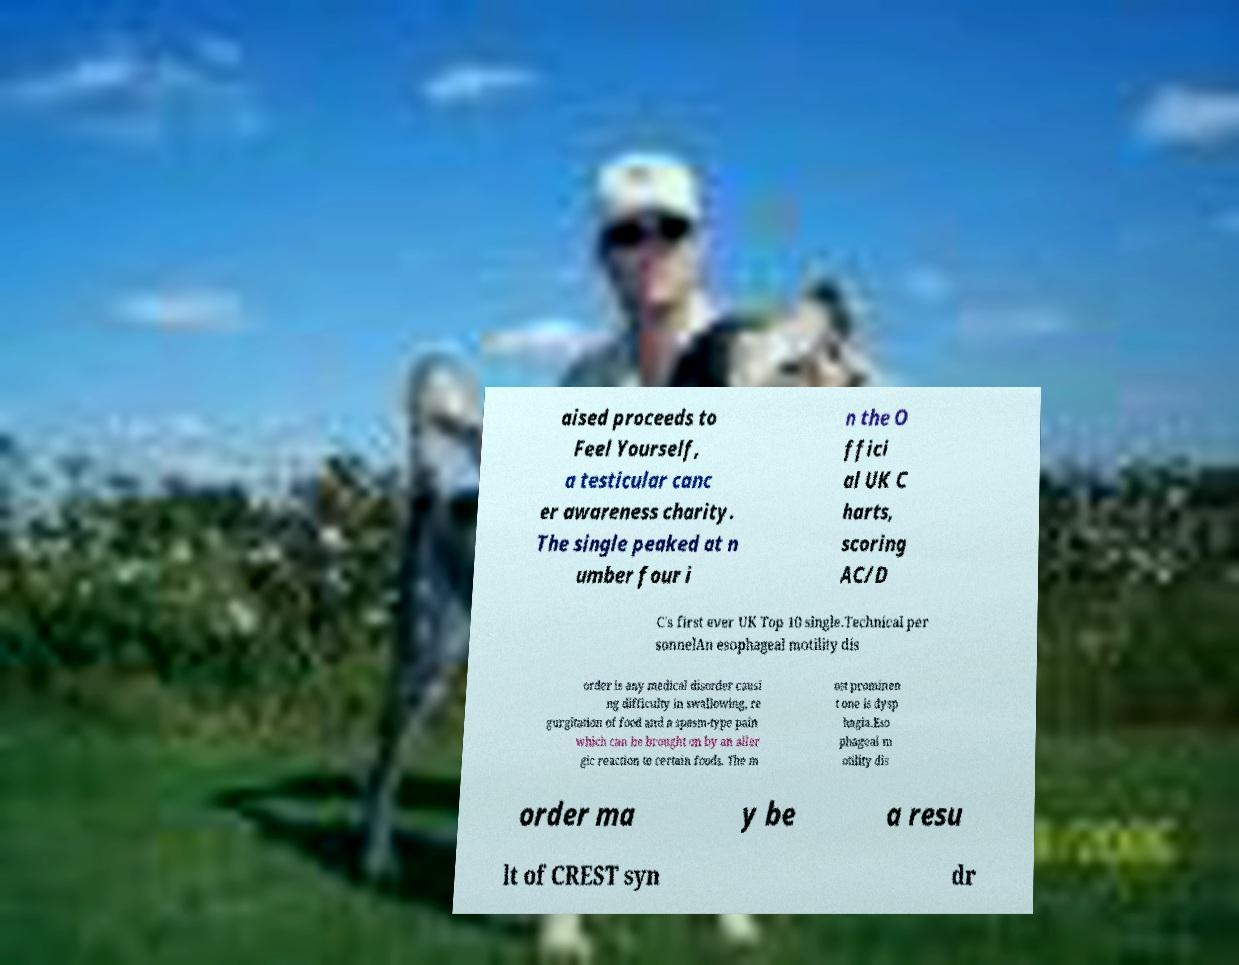Please identify and transcribe the text found in this image. aised proceeds to Feel Yourself, a testicular canc er awareness charity. The single peaked at n umber four i n the O ffici al UK C harts, scoring AC/D C's first ever UK Top 10 single.Technical per sonnelAn esophageal motility dis order is any medical disorder causi ng difficulty in swallowing, re gurgitation of food and a spasm-type pain which can be brought on by an aller gic reaction to certain foods. The m ost prominen t one is dysp hagia.Eso phageal m otility dis order ma y be a resu lt of CREST syn dr 